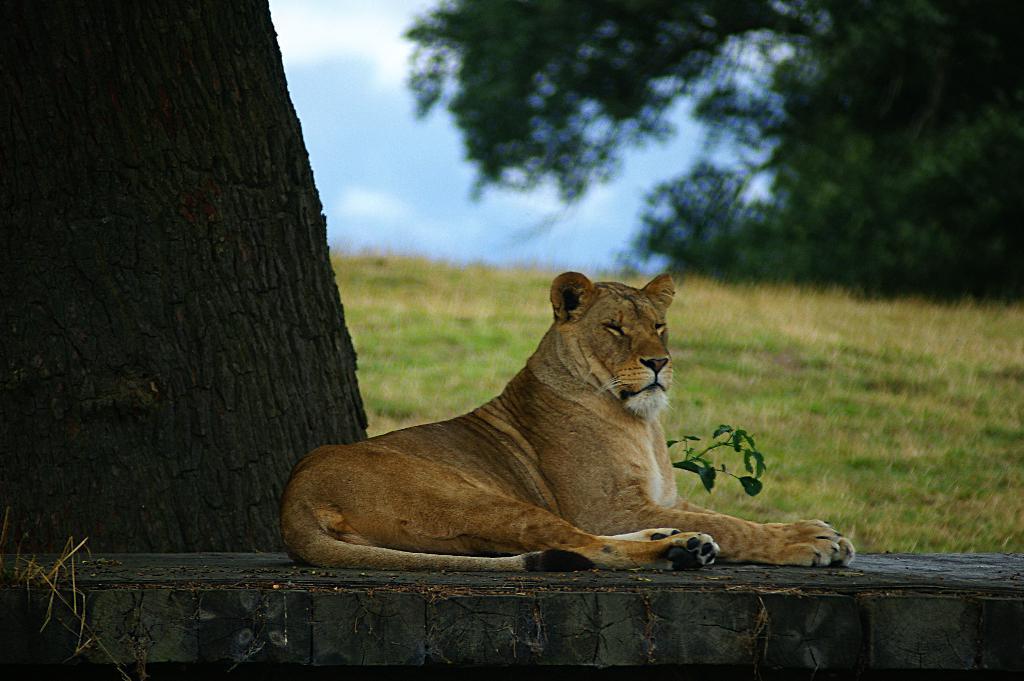In one or two sentences, can you explain what this image depicts? This image is taken outdoors. At the bottom of the image there is a wall. At the top of the image there is the sky with clouds. In the background there are a few trees and there is a ground with grass on it. On the left side of the image there is a tree. In the middle of the image there is a lion on the wall. 